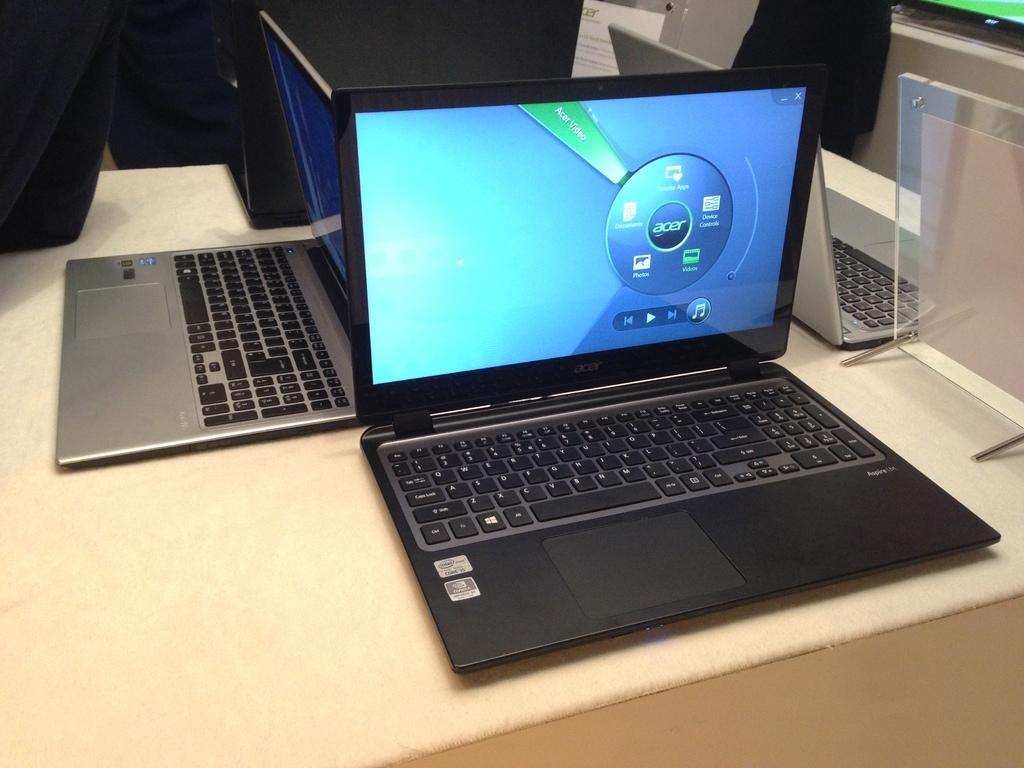What brand of laptop is this?
Provide a short and direct response. Acer. 